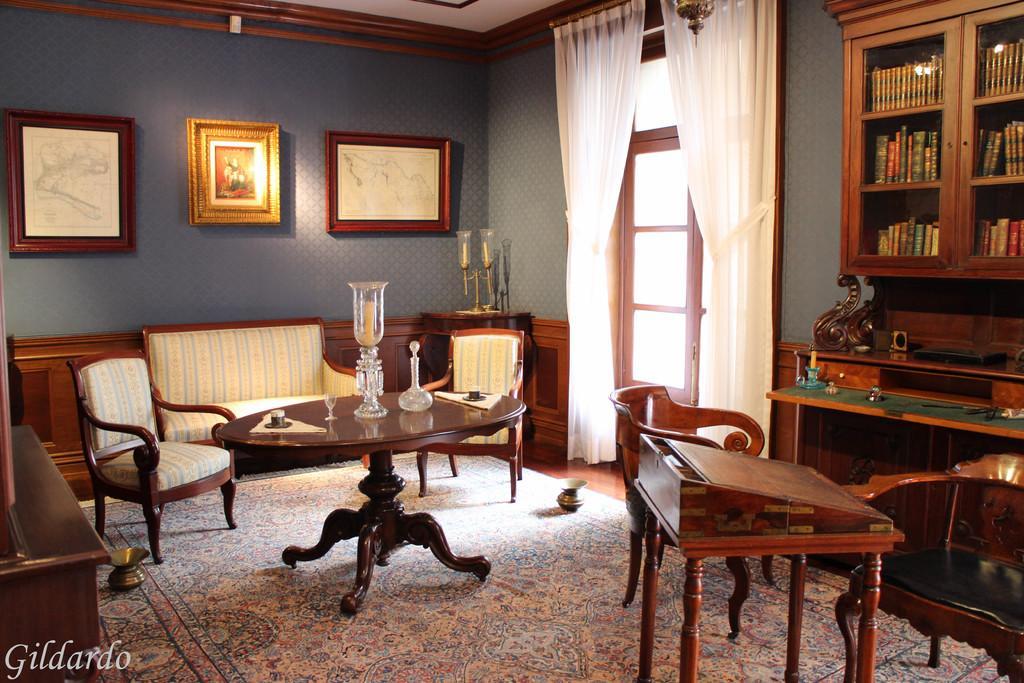Could you give a brief overview of what you see in this image? There is a table and chairs in front of it and there is a door,bookshelf and white curtains in the right side. 